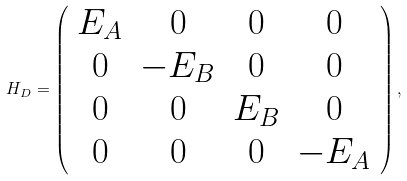Convert formula to latex. <formula><loc_0><loc_0><loc_500><loc_500>H _ { D } = \left ( \begin{array} { c c c c } E _ { A } & 0 & 0 & 0 \\ 0 & - E _ { B } & 0 & 0 \\ 0 & 0 & E _ { B } & 0 \\ 0 & 0 & 0 & - E _ { A } \end{array} \right ) ,</formula> 